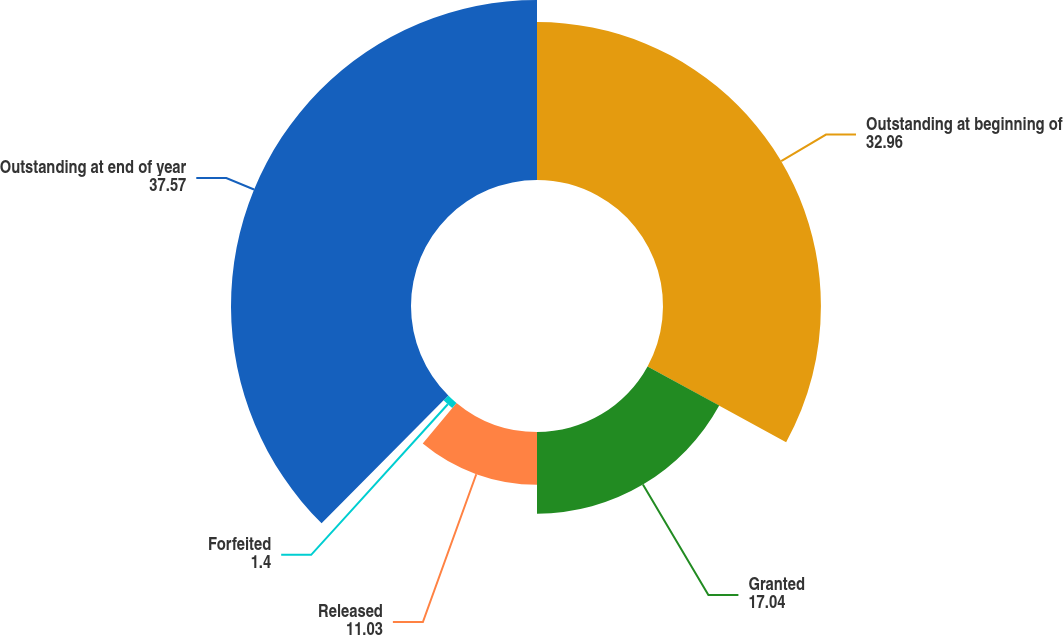Convert chart to OTSL. <chart><loc_0><loc_0><loc_500><loc_500><pie_chart><fcel>Outstanding at beginning of<fcel>Granted<fcel>Released<fcel>Forfeited<fcel>Outstanding at end of year<nl><fcel>32.96%<fcel>17.04%<fcel>11.03%<fcel>1.4%<fcel>37.57%<nl></chart> 